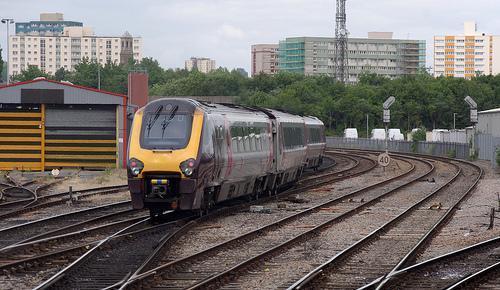How many trains are there?
Give a very brief answer. 1. How many train cars?
Give a very brief answer. 3. 